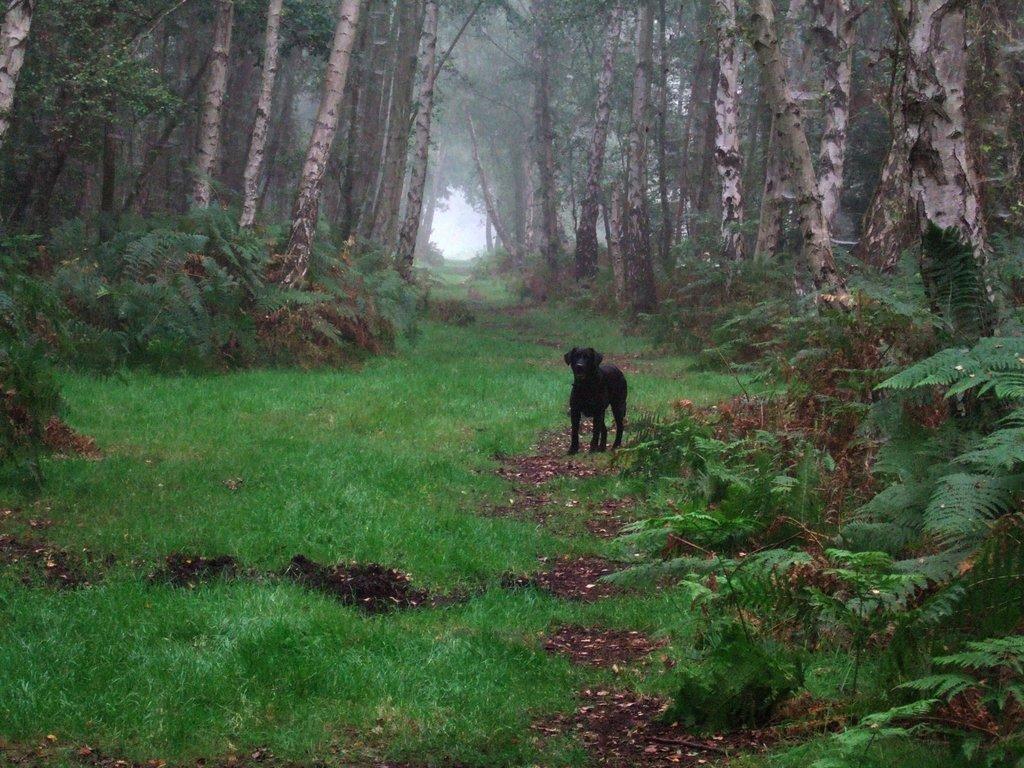Could you give a brief overview of what you see in this image? In the image in the center we can see one black color dog. In the background we can see trees,smoke,plants and grass. 